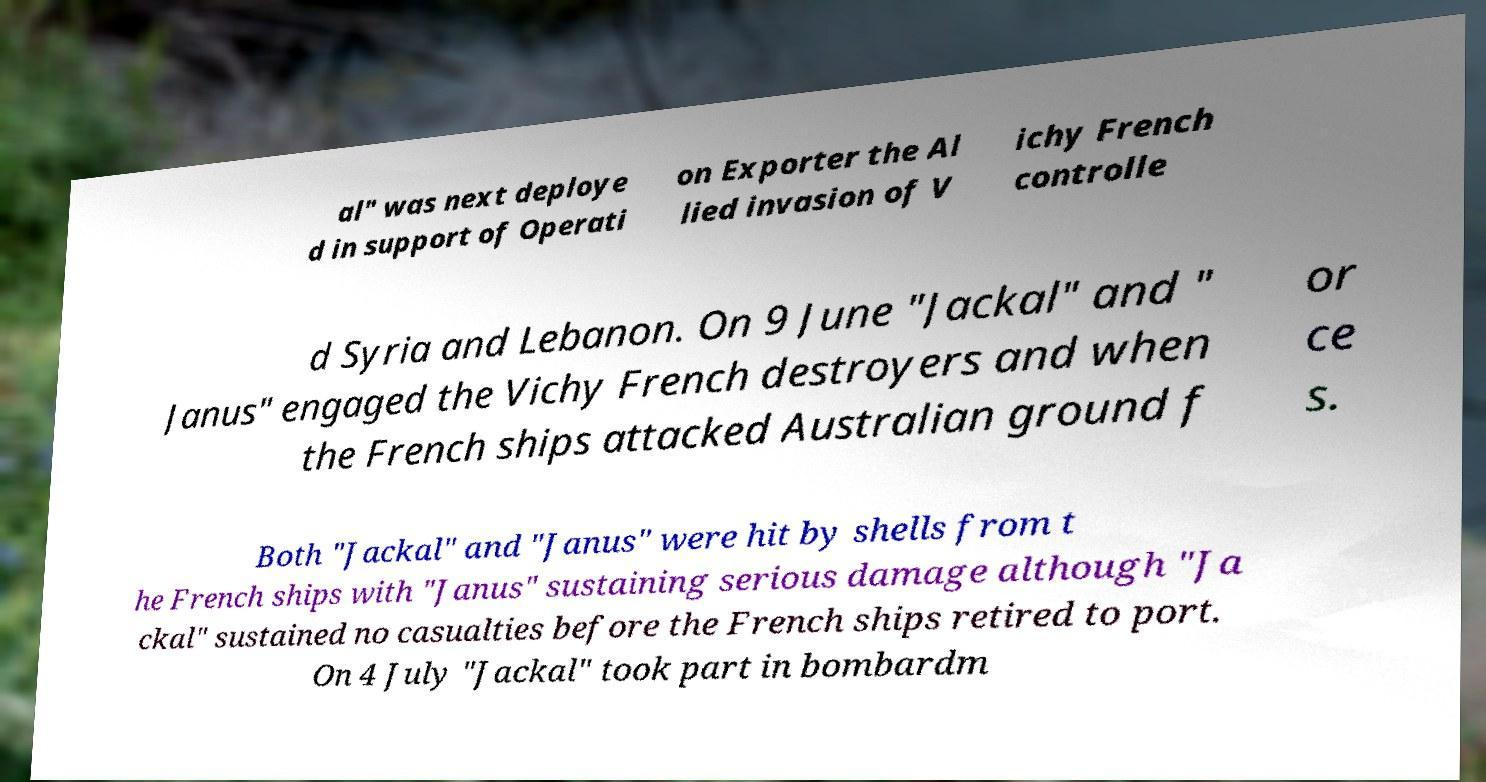For documentation purposes, I need the text within this image transcribed. Could you provide that? al" was next deploye d in support of Operati on Exporter the Al lied invasion of V ichy French controlle d Syria and Lebanon. On 9 June "Jackal" and " Janus" engaged the Vichy French destroyers and when the French ships attacked Australian ground f or ce s. Both "Jackal" and "Janus" were hit by shells from t he French ships with "Janus" sustaining serious damage although "Ja ckal" sustained no casualties before the French ships retired to port. On 4 July "Jackal" took part in bombardm 